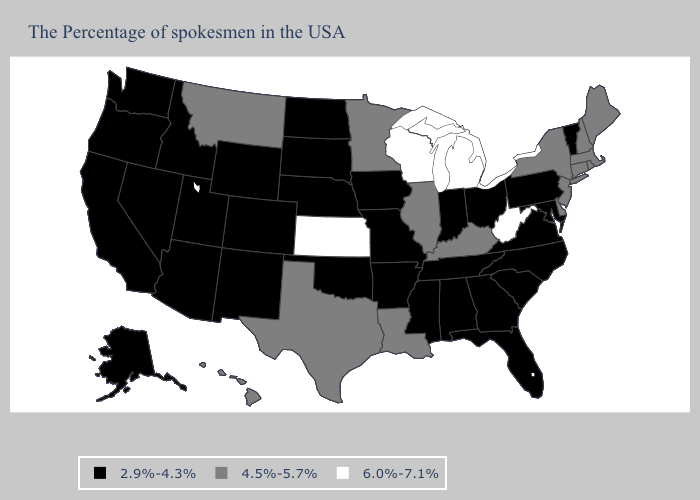What is the value of Georgia?
Quick response, please. 2.9%-4.3%. Does New Hampshire have the highest value in the Northeast?
Keep it brief. Yes. Which states have the highest value in the USA?
Give a very brief answer. West Virginia, Michigan, Wisconsin, Kansas. Which states hav the highest value in the South?
Short answer required. West Virginia. Is the legend a continuous bar?
Write a very short answer. No. Name the states that have a value in the range 4.5%-5.7%?
Write a very short answer. Maine, Massachusetts, Rhode Island, New Hampshire, Connecticut, New York, New Jersey, Delaware, Kentucky, Illinois, Louisiana, Minnesota, Texas, Montana, Hawaii. What is the highest value in states that border Idaho?
Write a very short answer. 4.5%-5.7%. What is the highest value in the MidWest ?
Short answer required. 6.0%-7.1%. Among the states that border Massachusetts , does Vermont have the highest value?
Be succinct. No. Name the states that have a value in the range 6.0%-7.1%?
Answer briefly. West Virginia, Michigan, Wisconsin, Kansas. Among the states that border Indiana , which have the highest value?
Be succinct. Michigan. Name the states that have a value in the range 2.9%-4.3%?
Keep it brief. Vermont, Maryland, Pennsylvania, Virginia, North Carolina, South Carolina, Ohio, Florida, Georgia, Indiana, Alabama, Tennessee, Mississippi, Missouri, Arkansas, Iowa, Nebraska, Oklahoma, South Dakota, North Dakota, Wyoming, Colorado, New Mexico, Utah, Arizona, Idaho, Nevada, California, Washington, Oregon, Alaska. Among the states that border North Dakota , does South Dakota have the lowest value?
Answer briefly. Yes. Name the states that have a value in the range 4.5%-5.7%?
Concise answer only. Maine, Massachusetts, Rhode Island, New Hampshire, Connecticut, New York, New Jersey, Delaware, Kentucky, Illinois, Louisiana, Minnesota, Texas, Montana, Hawaii. 